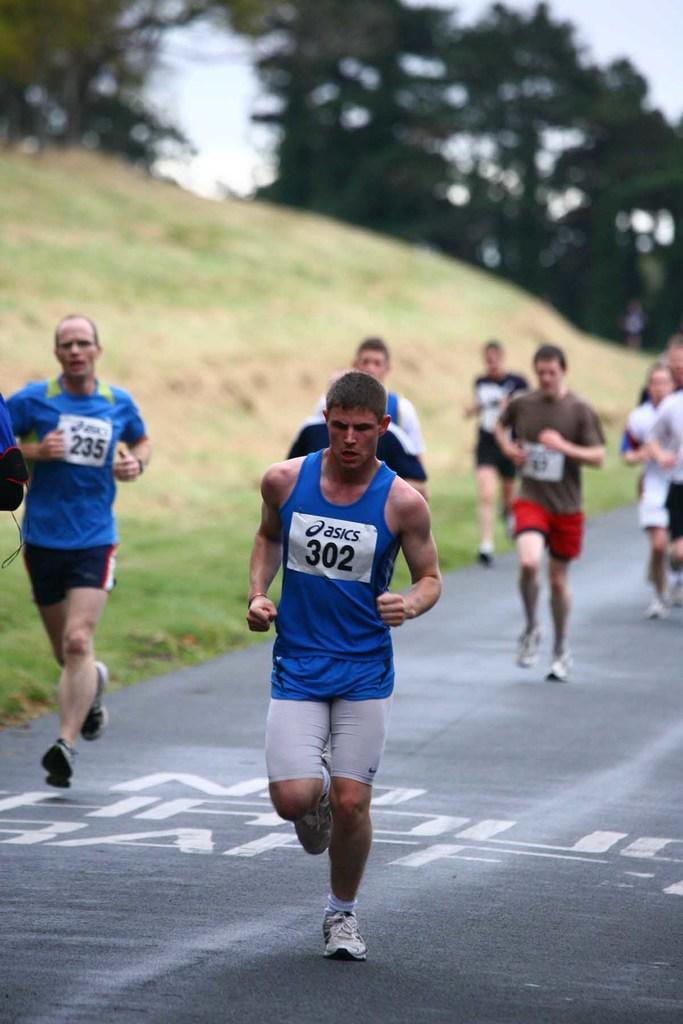What are the people in the image doing? The people in the image are running. What can be seen on the ground in the image? The ground is visible with grass in the image. What type of surface is the people running on? There is a road in the image, which is the surface the people are running on. What else can be seen in the image besides the people running? There are trees and the sky visible in the image. What type of oven can be seen in the image? There is no oven present in the image. What angle is the camera positioned at in the image? The angle of the camera cannot be determined from the image itself, as it is a two-dimensional representation. 